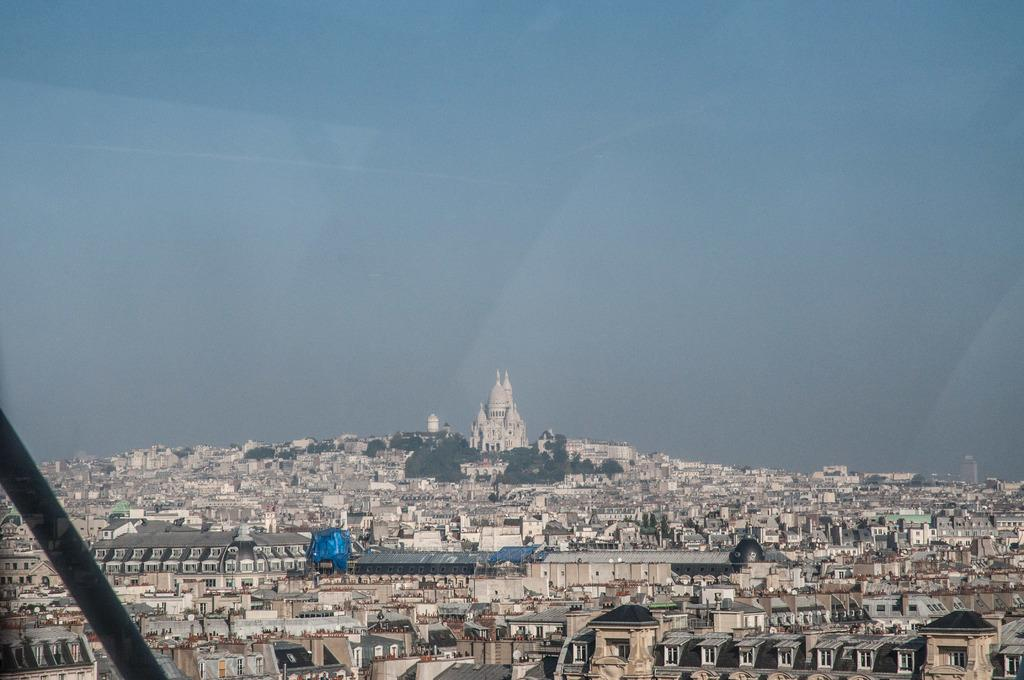What type of structures are present in the image? There is a group of buildings in the image. What other natural elements can be seen in the image? There are trees in the image. What is visible at the top of the image? The sky is visible at the top of the image. What type of bun is being used to create harmony among the buildings in the image? There is no bun present in the image, and the concept of harmony among the buildings is not applicable in this context. 